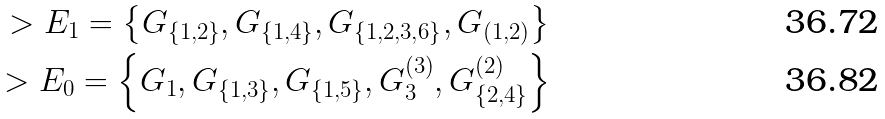<formula> <loc_0><loc_0><loc_500><loc_500>> { E } _ { 1 } = \left \{ G _ { \{ 1 , 2 \} } , G _ { \{ 1 , 4 \} } , G _ { \{ 1 , 2 , 3 , 6 \} } , G _ { ( 1 , 2 ) } \right \} \\ > { E } _ { 0 } = \left \{ G _ { 1 } , G _ { \{ 1 , 3 \} } , G _ { \{ 1 , 5 \} } , G _ { 3 } ^ { ( 3 ) } , G _ { \{ 2 , 4 \} } ^ { ( 2 ) } \right \}</formula> 